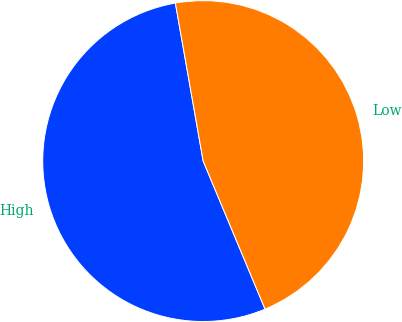Convert chart. <chart><loc_0><loc_0><loc_500><loc_500><pie_chart><fcel>High<fcel>Low<nl><fcel>53.53%<fcel>46.47%<nl></chart> 